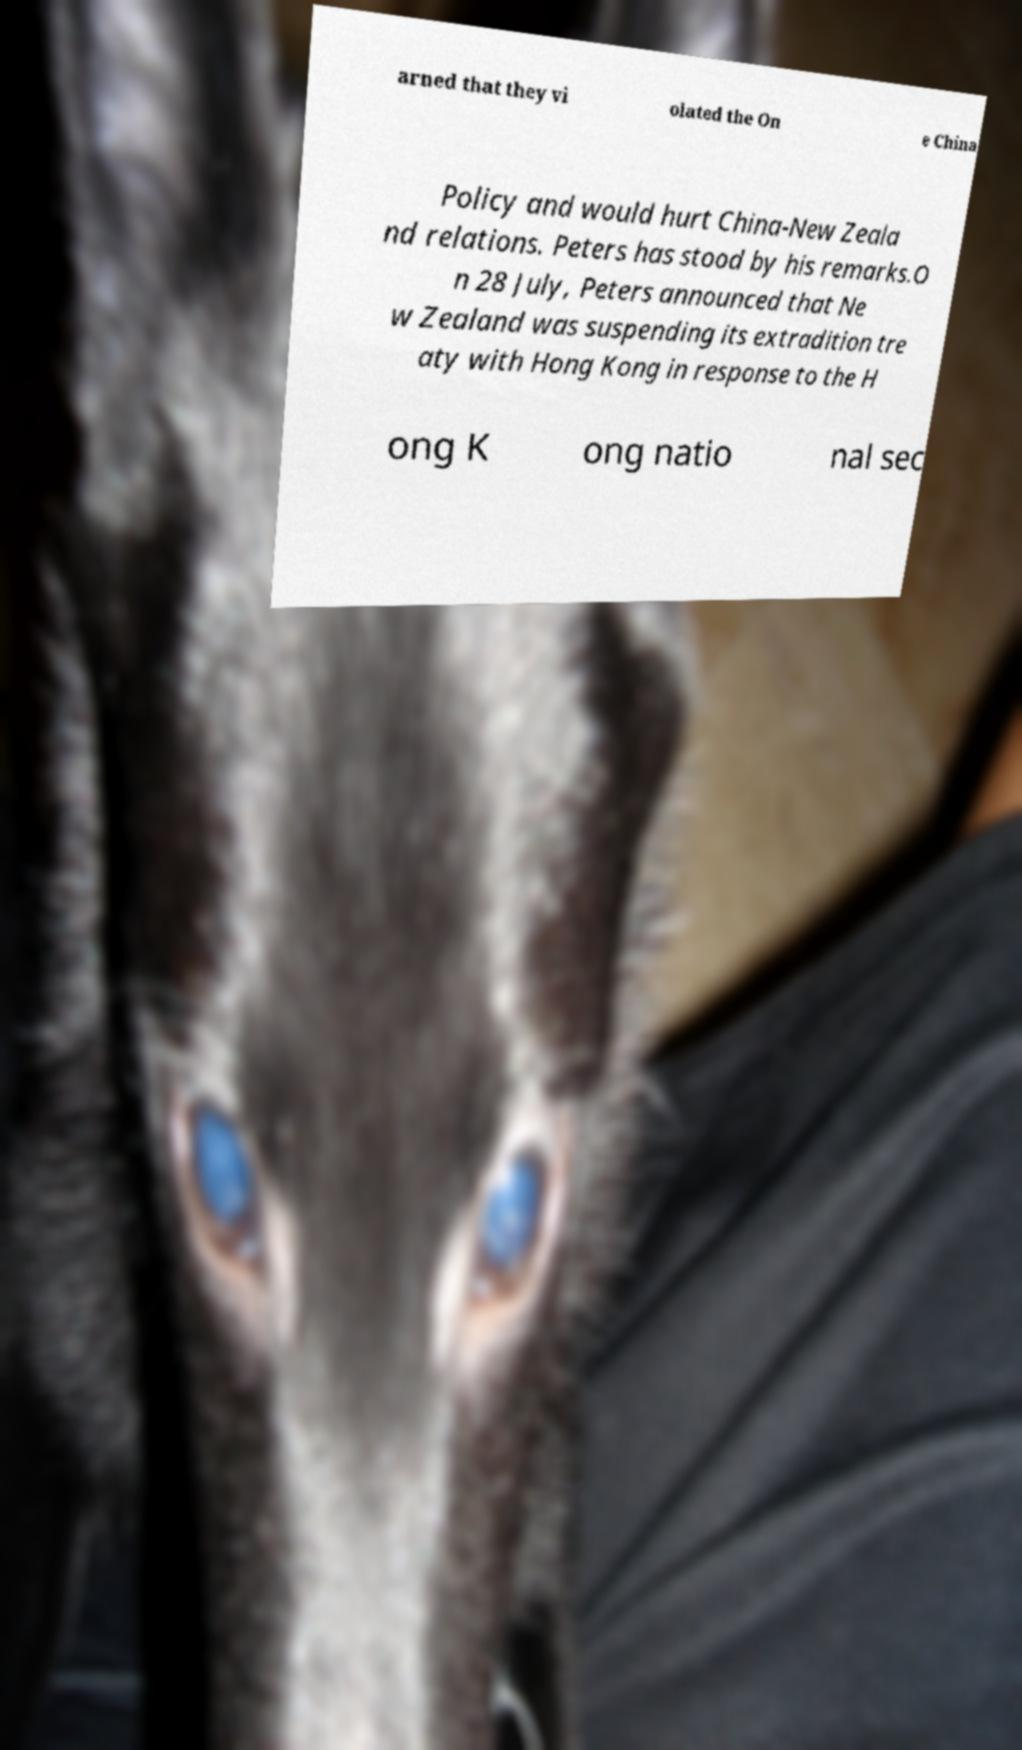Can you accurately transcribe the text from the provided image for me? arned that they vi olated the On e China Policy and would hurt China-New Zeala nd relations. Peters has stood by his remarks.O n 28 July, Peters announced that Ne w Zealand was suspending its extradition tre aty with Hong Kong in response to the H ong K ong natio nal sec 